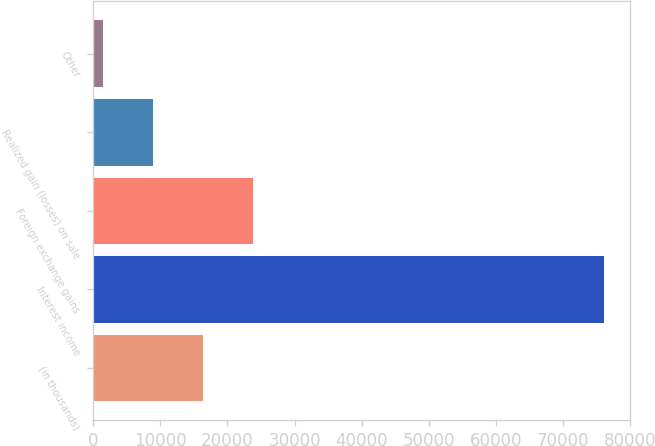Convert chart. <chart><loc_0><loc_0><loc_500><loc_500><bar_chart><fcel>(in thousands)<fcel>Interest income<fcel>Foreign exchange gains<fcel>Realized gain (losses) on sale<fcel>Other<nl><fcel>16354.6<fcel>76201<fcel>23835.4<fcel>8873.8<fcel>1393<nl></chart> 